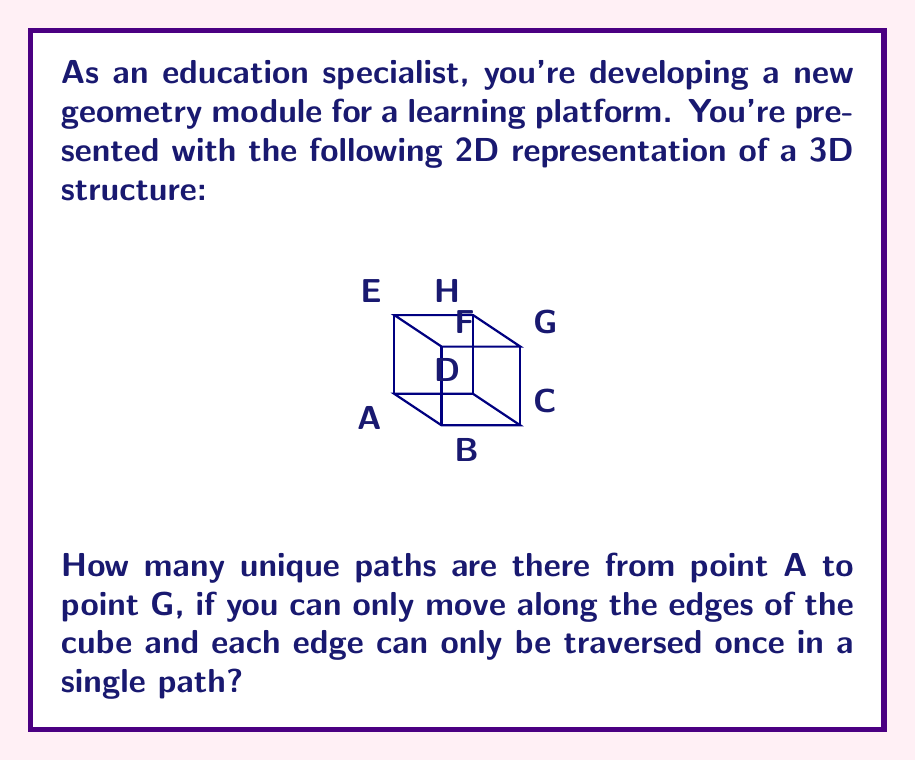Teach me how to tackle this problem. Let's approach this step-by-step:

1) First, we need to understand what the question is asking. We're looking for paths from A to G that:
   - Only move along the edges of the cube
   - Never use the same edge twice in a single path
   - Always end at G

2) To reach G from A, we need to move:
   - 1 unit in the x-direction
   - 1 unit in the y-direction
   - 1 unit in the z-direction

3) The order in which we make these movements will determine our path. There are 3! = 6 possible orders:
   - x, y, z
   - x, z, y
   - y, x, z
   - y, z, x
   - z, x, y
   - z, y, x

4) Let's count the paths for each order:

   x, y, z: A → B → C → G (1 path)
   x, z, y: A → B → F → G (1 path)
   y, x, z: A → D → C → G (1 path)
   y, z, x: A → D → H → G (1 path)
   z, x, y: A → E → F → G (1 path)
   z, y, x: A → E → H → G (1 path)

5) Adding up all these paths: 1 + 1 + 1 + 1 + 1 + 1 = 6

Therefore, there are 6 unique paths from A to G that satisfy the given conditions.
Answer: 6 